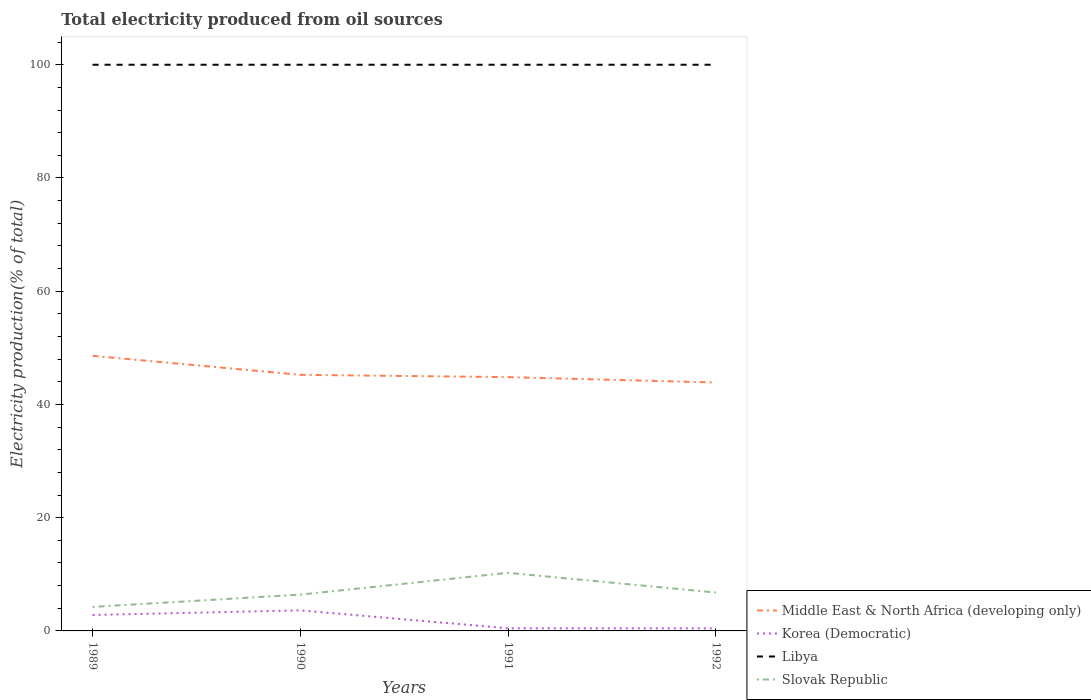Does the line corresponding to Libya intersect with the line corresponding to Middle East & North Africa (developing only)?
Your answer should be very brief. No. What is the total total electricity produced in Middle East & North Africa (developing only) in the graph?
Your answer should be compact. 4.71. What is the difference between the highest and the second highest total electricity produced in Korea (Democratic)?
Provide a succinct answer. 3.18. How many lines are there?
Offer a very short reply. 4. What is the difference between two consecutive major ticks on the Y-axis?
Make the answer very short. 20. Does the graph contain any zero values?
Keep it short and to the point. No. Does the graph contain grids?
Your answer should be very brief. No. Where does the legend appear in the graph?
Provide a succinct answer. Bottom right. How many legend labels are there?
Offer a terse response. 4. What is the title of the graph?
Offer a very short reply. Total electricity produced from oil sources. What is the Electricity production(% of total) of Middle East & North Africa (developing only) in 1989?
Your answer should be very brief. 48.59. What is the Electricity production(% of total) in Korea (Democratic) in 1989?
Your response must be concise. 2.82. What is the Electricity production(% of total) in Slovak Republic in 1989?
Ensure brevity in your answer.  4.24. What is the Electricity production(% of total) in Middle East & North Africa (developing only) in 1990?
Keep it short and to the point. 45.23. What is the Electricity production(% of total) in Korea (Democratic) in 1990?
Give a very brief answer. 3.63. What is the Electricity production(% of total) of Slovak Republic in 1990?
Make the answer very short. 6.41. What is the Electricity production(% of total) in Middle East & North Africa (developing only) in 1991?
Your answer should be compact. 44.82. What is the Electricity production(% of total) in Korea (Democratic) in 1991?
Give a very brief answer. 0.47. What is the Electricity production(% of total) in Libya in 1991?
Provide a short and direct response. 100. What is the Electricity production(% of total) in Slovak Republic in 1991?
Your response must be concise. 10.26. What is the Electricity production(% of total) of Middle East & North Africa (developing only) in 1992?
Your response must be concise. 43.88. What is the Electricity production(% of total) in Korea (Democratic) in 1992?
Your response must be concise. 0.45. What is the Electricity production(% of total) of Libya in 1992?
Provide a succinct answer. 100. What is the Electricity production(% of total) of Slovak Republic in 1992?
Offer a very short reply. 6.78. Across all years, what is the maximum Electricity production(% of total) of Middle East & North Africa (developing only)?
Your response must be concise. 48.59. Across all years, what is the maximum Electricity production(% of total) in Korea (Democratic)?
Your response must be concise. 3.63. Across all years, what is the maximum Electricity production(% of total) in Slovak Republic?
Make the answer very short. 10.26. Across all years, what is the minimum Electricity production(% of total) of Middle East & North Africa (developing only)?
Offer a very short reply. 43.88. Across all years, what is the minimum Electricity production(% of total) of Korea (Democratic)?
Ensure brevity in your answer.  0.45. Across all years, what is the minimum Electricity production(% of total) of Libya?
Provide a short and direct response. 100. Across all years, what is the minimum Electricity production(% of total) in Slovak Republic?
Your answer should be very brief. 4.24. What is the total Electricity production(% of total) of Middle East & North Africa (developing only) in the graph?
Offer a very short reply. 182.53. What is the total Electricity production(% of total) in Korea (Democratic) in the graph?
Provide a succinct answer. 7.37. What is the total Electricity production(% of total) in Slovak Republic in the graph?
Provide a short and direct response. 27.7. What is the difference between the Electricity production(% of total) of Middle East & North Africa (developing only) in 1989 and that in 1990?
Provide a succinct answer. 3.36. What is the difference between the Electricity production(% of total) of Korea (Democratic) in 1989 and that in 1990?
Your response must be concise. -0.82. What is the difference between the Electricity production(% of total) in Libya in 1989 and that in 1990?
Make the answer very short. 0. What is the difference between the Electricity production(% of total) of Slovak Republic in 1989 and that in 1990?
Provide a short and direct response. -2.17. What is the difference between the Electricity production(% of total) in Middle East & North Africa (developing only) in 1989 and that in 1991?
Provide a succinct answer. 3.77. What is the difference between the Electricity production(% of total) in Korea (Democratic) in 1989 and that in 1991?
Your answer should be compact. 2.35. What is the difference between the Electricity production(% of total) in Libya in 1989 and that in 1991?
Offer a very short reply. 0. What is the difference between the Electricity production(% of total) of Slovak Republic in 1989 and that in 1991?
Offer a very short reply. -6.02. What is the difference between the Electricity production(% of total) in Middle East & North Africa (developing only) in 1989 and that in 1992?
Offer a very short reply. 4.71. What is the difference between the Electricity production(% of total) in Korea (Democratic) in 1989 and that in 1992?
Keep it short and to the point. 2.36. What is the difference between the Electricity production(% of total) of Libya in 1989 and that in 1992?
Offer a very short reply. 0. What is the difference between the Electricity production(% of total) of Slovak Republic in 1989 and that in 1992?
Give a very brief answer. -2.54. What is the difference between the Electricity production(% of total) in Middle East & North Africa (developing only) in 1990 and that in 1991?
Keep it short and to the point. 0.41. What is the difference between the Electricity production(% of total) of Korea (Democratic) in 1990 and that in 1991?
Offer a very short reply. 3.16. What is the difference between the Electricity production(% of total) in Libya in 1990 and that in 1991?
Ensure brevity in your answer.  0. What is the difference between the Electricity production(% of total) in Slovak Republic in 1990 and that in 1991?
Make the answer very short. -3.85. What is the difference between the Electricity production(% of total) in Middle East & North Africa (developing only) in 1990 and that in 1992?
Keep it short and to the point. 1.36. What is the difference between the Electricity production(% of total) in Korea (Democratic) in 1990 and that in 1992?
Offer a terse response. 3.18. What is the difference between the Electricity production(% of total) in Slovak Republic in 1990 and that in 1992?
Give a very brief answer. -0.37. What is the difference between the Electricity production(% of total) of Middle East & North Africa (developing only) in 1991 and that in 1992?
Make the answer very short. 0.95. What is the difference between the Electricity production(% of total) of Korea (Democratic) in 1991 and that in 1992?
Your answer should be compact. 0.01. What is the difference between the Electricity production(% of total) of Libya in 1991 and that in 1992?
Offer a very short reply. 0. What is the difference between the Electricity production(% of total) in Slovak Republic in 1991 and that in 1992?
Make the answer very short. 3.48. What is the difference between the Electricity production(% of total) of Middle East & North Africa (developing only) in 1989 and the Electricity production(% of total) of Korea (Democratic) in 1990?
Offer a very short reply. 44.96. What is the difference between the Electricity production(% of total) of Middle East & North Africa (developing only) in 1989 and the Electricity production(% of total) of Libya in 1990?
Your response must be concise. -51.41. What is the difference between the Electricity production(% of total) of Middle East & North Africa (developing only) in 1989 and the Electricity production(% of total) of Slovak Republic in 1990?
Make the answer very short. 42.18. What is the difference between the Electricity production(% of total) of Korea (Democratic) in 1989 and the Electricity production(% of total) of Libya in 1990?
Ensure brevity in your answer.  -97.18. What is the difference between the Electricity production(% of total) in Korea (Democratic) in 1989 and the Electricity production(% of total) in Slovak Republic in 1990?
Your answer should be compact. -3.6. What is the difference between the Electricity production(% of total) of Libya in 1989 and the Electricity production(% of total) of Slovak Republic in 1990?
Offer a terse response. 93.59. What is the difference between the Electricity production(% of total) of Middle East & North Africa (developing only) in 1989 and the Electricity production(% of total) of Korea (Democratic) in 1991?
Make the answer very short. 48.13. What is the difference between the Electricity production(% of total) in Middle East & North Africa (developing only) in 1989 and the Electricity production(% of total) in Libya in 1991?
Your response must be concise. -51.41. What is the difference between the Electricity production(% of total) in Middle East & North Africa (developing only) in 1989 and the Electricity production(% of total) in Slovak Republic in 1991?
Your answer should be very brief. 38.33. What is the difference between the Electricity production(% of total) of Korea (Democratic) in 1989 and the Electricity production(% of total) of Libya in 1991?
Provide a short and direct response. -97.18. What is the difference between the Electricity production(% of total) in Korea (Democratic) in 1989 and the Electricity production(% of total) in Slovak Republic in 1991?
Give a very brief answer. -7.45. What is the difference between the Electricity production(% of total) of Libya in 1989 and the Electricity production(% of total) of Slovak Republic in 1991?
Provide a short and direct response. 89.74. What is the difference between the Electricity production(% of total) in Middle East & North Africa (developing only) in 1989 and the Electricity production(% of total) in Korea (Democratic) in 1992?
Ensure brevity in your answer.  48.14. What is the difference between the Electricity production(% of total) in Middle East & North Africa (developing only) in 1989 and the Electricity production(% of total) in Libya in 1992?
Provide a succinct answer. -51.41. What is the difference between the Electricity production(% of total) of Middle East & North Africa (developing only) in 1989 and the Electricity production(% of total) of Slovak Republic in 1992?
Provide a short and direct response. 41.81. What is the difference between the Electricity production(% of total) in Korea (Democratic) in 1989 and the Electricity production(% of total) in Libya in 1992?
Provide a short and direct response. -97.18. What is the difference between the Electricity production(% of total) in Korea (Democratic) in 1989 and the Electricity production(% of total) in Slovak Republic in 1992?
Ensure brevity in your answer.  -3.97. What is the difference between the Electricity production(% of total) in Libya in 1989 and the Electricity production(% of total) in Slovak Republic in 1992?
Offer a terse response. 93.22. What is the difference between the Electricity production(% of total) in Middle East & North Africa (developing only) in 1990 and the Electricity production(% of total) in Korea (Democratic) in 1991?
Give a very brief answer. 44.77. What is the difference between the Electricity production(% of total) in Middle East & North Africa (developing only) in 1990 and the Electricity production(% of total) in Libya in 1991?
Your response must be concise. -54.77. What is the difference between the Electricity production(% of total) in Middle East & North Africa (developing only) in 1990 and the Electricity production(% of total) in Slovak Republic in 1991?
Keep it short and to the point. 34.97. What is the difference between the Electricity production(% of total) of Korea (Democratic) in 1990 and the Electricity production(% of total) of Libya in 1991?
Keep it short and to the point. -96.37. What is the difference between the Electricity production(% of total) in Korea (Democratic) in 1990 and the Electricity production(% of total) in Slovak Republic in 1991?
Make the answer very short. -6.63. What is the difference between the Electricity production(% of total) of Libya in 1990 and the Electricity production(% of total) of Slovak Republic in 1991?
Your answer should be compact. 89.74. What is the difference between the Electricity production(% of total) in Middle East & North Africa (developing only) in 1990 and the Electricity production(% of total) in Korea (Democratic) in 1992?
Your answer should be very brief. 44.78. What is the difference between the Electricity production(% of total) in Middle East & North Africa (developing only) in 1990 and the Electricity production(% of total) in Libya in 1992?
Provide a succinct answer. -54.77. What is the difference between the Electricity production(% of total) of Middle East & North Africa (developing only) in 1990 and the Electricity production(% of total) of Slovak Republic in 1992?
Offer a very short reply. 38.45. What is the difference between the Electricity production(% of total) in Korea (Democratic) in 1990 and the Electricity production(% of total) in Libya in 1992?
Keep it short and to the point. -96.37. What is the difference between the Electricity production(% of total) in Korea (Democratic) in 1990 and the Electricity production(% of total) in Slovak Republic in 1992?
Your answer should be compact. -3.15. What is the difference between the Electricity production(% of total) in Libya in 1990 and the Electricity production(% of total) in Slovak Republic in 1992?
Keep it short and to the point. 93.22. What is the difference between the Electricity production(% of total) in Middle East & North Africa (developing only) in 1991 and the Electricity production(% of total) in Korea (Democratic) in 1992?
Give a very brief answer. 44.37. What is the difference between the Electricity production(% of total) in Middle East & North Africa (developing only) in 1991 and the Electricity production(% of total) in Libya in 1992?
Make the answer very short. -55.18. What is the difference between the Electricity production(% of total) in Middle East & North Africa (developing only) in 1991 and the Electricity production(% of total) in Slovak Republic in 1992?
Offer a terse response. 38.04. What is the difference between the Electricity production(% of total) of Korea (Democratic) in 1991 and the Electricity production(% of total) of Libya in 1992?
Give a very brief answer. -99.53. What is the difference between the Electricity production(% of total) of Korea (Democratic) in 1991 and the Electricity production(% of total) of Slovak Republic in 1992?
Your answer should be compact. -6.32. What is the difference between the Electricity production(% of total) of Libya in 1991 and the Electricity production(% of total) of Slovak Republic in 1992?
Your response must be concise. 93.22. What is the average Electricity production(% of total) of Middle East & North Africa (developing only) per year?
Offer a very short reply. 45.63. What is the average Electricity production(% of total) in Korea (Democratic) per year?
Make the answer very short. 1.84. What is the average Electricity production(% of total) in Libya per year?
Offer a terse response. 100. What is the average Electricity production(% of total) in Slovak Republic per year?
Your response must be concise. 6.92. In the year 1989, what is the difference between the Electricity production(% of total) of Middle East & North Africa (developing only) and Electricity production(% of total) of Korea (Democratic)?
Make the answer very short. 45.78. In the year 1989, what is the difference between the Electricity production(% of total) of Middle East & North Africa (developing only) and Electricity production(% of total) of Libya?
Give a very brief answer. -51.41. In the year 1989, what is the difference between the Electricity production(% of total) in Middle East & North Africa (developing only) and Electricity production(% of total) in Slovak Republic?
Offer a very short reply. 44.35. In the year 1989, what is the difference between the Electricity production(% of total) of Korea (Democratic) and Electricity production(% of total) of Libya?
Make the answer very short. -97.18. In the year 1989, what is the difference between the Electricity production(% of total) of Korea (Democratic) and Electricity production(% of total) of Slovak Republic?
Give a very brief answer. -1.42. In the year 1989, what is the difference between the Electricity production(% of total) of Libya and Electricity production(% of total) of Slovak Republic?
Keep it short and to the point. 95.76. In the year 1990, what is the difference between the Electricity production(% of total) of Middle East & North Africa (developing only) and Electricity production(% of total) of Korea (Democratic)?
Offer a terse response. 41.6. In the year 1990, what is the difference between the Electricity production(% of total) in Middle East & North Africa (developing only) and Electricity production(% of total) in Libya?
Ensure brevity in your answer.  -54.77. In the year 1990, what is the difference between the Electricity production(% of total) in Middle East & North Africa (developing only) and Electricity production(% of total) in Slovak Republic?
Your answer should be very brief. 38.82. In the year 1990, what is the difference between the Electricity production(% of total) of Korea (Democratic) and Electricity production(% of total) of Libya?
Your response must be concise. -96.37. In the year 1990, what is the difference between the Electricity production(% of total) in Korea (Democratic) and Electricity production(% of total) in Slovak Republic?
Provide a short and direct response. -2.78. In the year 1990, what is the difference between the Electricity production(% of total) in Libya and Electricity production(% of total) in Slovak Republic?
Offer a terse response. 93.59. In the year 1991, what is the difference between the Electricity production(% of total) of Middle East & North Africa (developing only) and Electricity production(% of total) of Korea (Democratic)?
Ensure brevity in your answer.  44.36. In the year 1991, what is the difference between the Electricity production(% of total) of Middle East & North Africa (developing only) and Electricity production(% of total) of Libya?
Your answer should be very brief. -55.18. In the year 1991, what is the difference between the Electricity production(% of total) in Middle East & North Africa (developing only) and Electricity production(% of total) in Slovak Republic?
Offer a terse response. 34.56. In the year 1991, what is the difference between the Electricity production(% of total) in Korea (Democratic) and Electricity production(% of total) in Libya?
Provide a short and direct response. -99.53. In the year 1991, what is the difference between the Electricity production(% of total) of Korea (Democratic) and Electricity production(% of total) of Slovak Republic?
Give a very brief answer. -9.8. In the year 1991, what is the difference between the Electricity production(% of total) of Libya and Electricity production(% of total) of Slovak Republic?
Give a very brief answer. 89.74. In the year 1992, what is the difference between the Electricity production(% of total) of Middle East & North Africa (developing only) and Electricity production(% of total) of Korea (Democratic)?
Your answer should be compact. 43.42. In the year 1992, what is the difference between the Electricity production(% of total) of Middle East & North Africa (developing only) and Electricity production(% of total) of Libya?
Give a very brief answer. -56.12. In the year 1992, what is the difference between the Electricity production(% of total) in Middle East & North Africa (developing only) and Electricity production(% of total) in Slovak Republic?
Provide a short and direct response. 37.09. In the year 1992, what is the difference between the Electricity production(% of total) in Korea (Democratic) and Electricity production(% of total) in Libya?
Keep it short and to the point. -99.55. In the year 1992, what is the difference between the Electricity production(% of total) in Korea (Democratic) and Electricity production(% of total) in Slovak Republic?
Offer a very short reply. -6.33. In the year 1992, what is the difference between the Electricity production(% of total) in Libya and Electricity production(% of total) in Slovak Republic?
Your answer should be compact. 93.22. What is the ratio of the Electricity production(% of total) in Middle East & North Africa (developing only) in 1989 to that in 1990?
Give a very brief answer. 1.07. What is the ratio of the Electricity production(% of total) in Korea (Democratic) in 1989 to that in 1990?
Your answer should be compact. 0.78. What is the ratio of the Electricity production(% of total) in Slovak Republic in 1989 to that in 1990?
Offer a terse response. 0.66. What is the ratio of the Electricity production(% of total) of Middle East & North Africa (developing only) in 1989 to that in 1991?
Make the answer very short. 1.08. What is the ratio of the Electricity production(% of total) of Korea (Democratic) in 1989 to that in 1991?
Ensure brevity in your answer.  6.02. What is the ratio of the Electricity production(% of total) of Libya in 1989 to that in 1991?
Ensure brevity in your answer.  1. What is the ratio of the Electricity production(% of total) in Slovak Republic in 1989 to that in 1991?
Keep it short and to the point. 0.41. What is the ratio of the Electricity production(% of total) of Middle East & North Africa (developing only) in 1989 to that in 1992?
Keep it short and to the point. 1.11. What is the ratio of the Electricity production(% of total) in Korea (Democratic) in 1989 to that in 1992?
Your response must be concise. 6.21. What is the ratio of the Electricity production(% of total) of Slovak Republic in 1989 to that in 1992?
Provide a succinct answer. 0.62. What is the ratio of the Electricity production(% of total) of Middle East & North Africa (developing only) in 1990 to that in 1991?
Your response must be concise. 1.01. What is the ratio of the Electricity production(% of total) in Korea (Democratic) in 1990 to that in 1991?
Give a very brief answer. 7.77. What is the ratio of the Electricity production(% of total) of Libya in 1990 to that in 1991?
Make the answer very short. 1. What is the ratio of the Electricity production(% of total) of Slovak Republic in 1990 to that in 1991?
Provide a short and direct response. 0.62. What is the ratio of the Electricity production(% of total) in Middle East & North Africa (developing only) in 1990 to that in 1992?
Give a very brief answer. 1.03. What is the ratio of the Electricity production(% of total) in Korea (Democratic) in 1990 to that in 1992?
Provide a succinct answer. 8.01. What is the ratio of the Electricity production(% of total) of Slovak Republic in 1990 to that in 1992?
Ensure brevity in your answer.  0.95. What is the ratio of the Electricity production(% of total) of Middle East & North Africa (developing only) in 1991 to that in 1992?
Offer a very short reply. 1.02. What is the ratio of the Electricity production(% of total) in Korea (Democratic) in 1991 to that in 1992?
Ensure brevity in your answer.  1.03. What is the ratio of the Electricity production(% of total) of Libya in 1991 to that in 1992?
Give a very brief answer. 1. What is the ratio of the Electricity production(% of total) in Slovak Republic in 1991 to that in 1992?
Keep it short and to the point. 1.51. What is the difference between the highest and the second highest Electricity production(% of total) of Middle East & North Africa (developing only)?
Provide a short and direct response. 3.36. What is the difference between the highest and the second highest Electricity production(% of total) in Korea (Democratic)?
Your answer should be very brief. 0.82. What is the difference between the highest and the second highest Electricity production(% of total) of Slovak Republic?
Offer a terse response. 3.48. What is the difference between the highest and the lowest Electricity production(% of total) of Middle East & North Africa (developing only)?
Offer a very short reply. 4.71. What is the difference between the highest and the lowest Electricity production(% of total) in Korea (Democratic)?
Offer a very short reply. 3.18. What is the difference between the highest and the lowest Electricity production(% of total) of Slovak Republic?
Give a very brief answer. 6.02. 